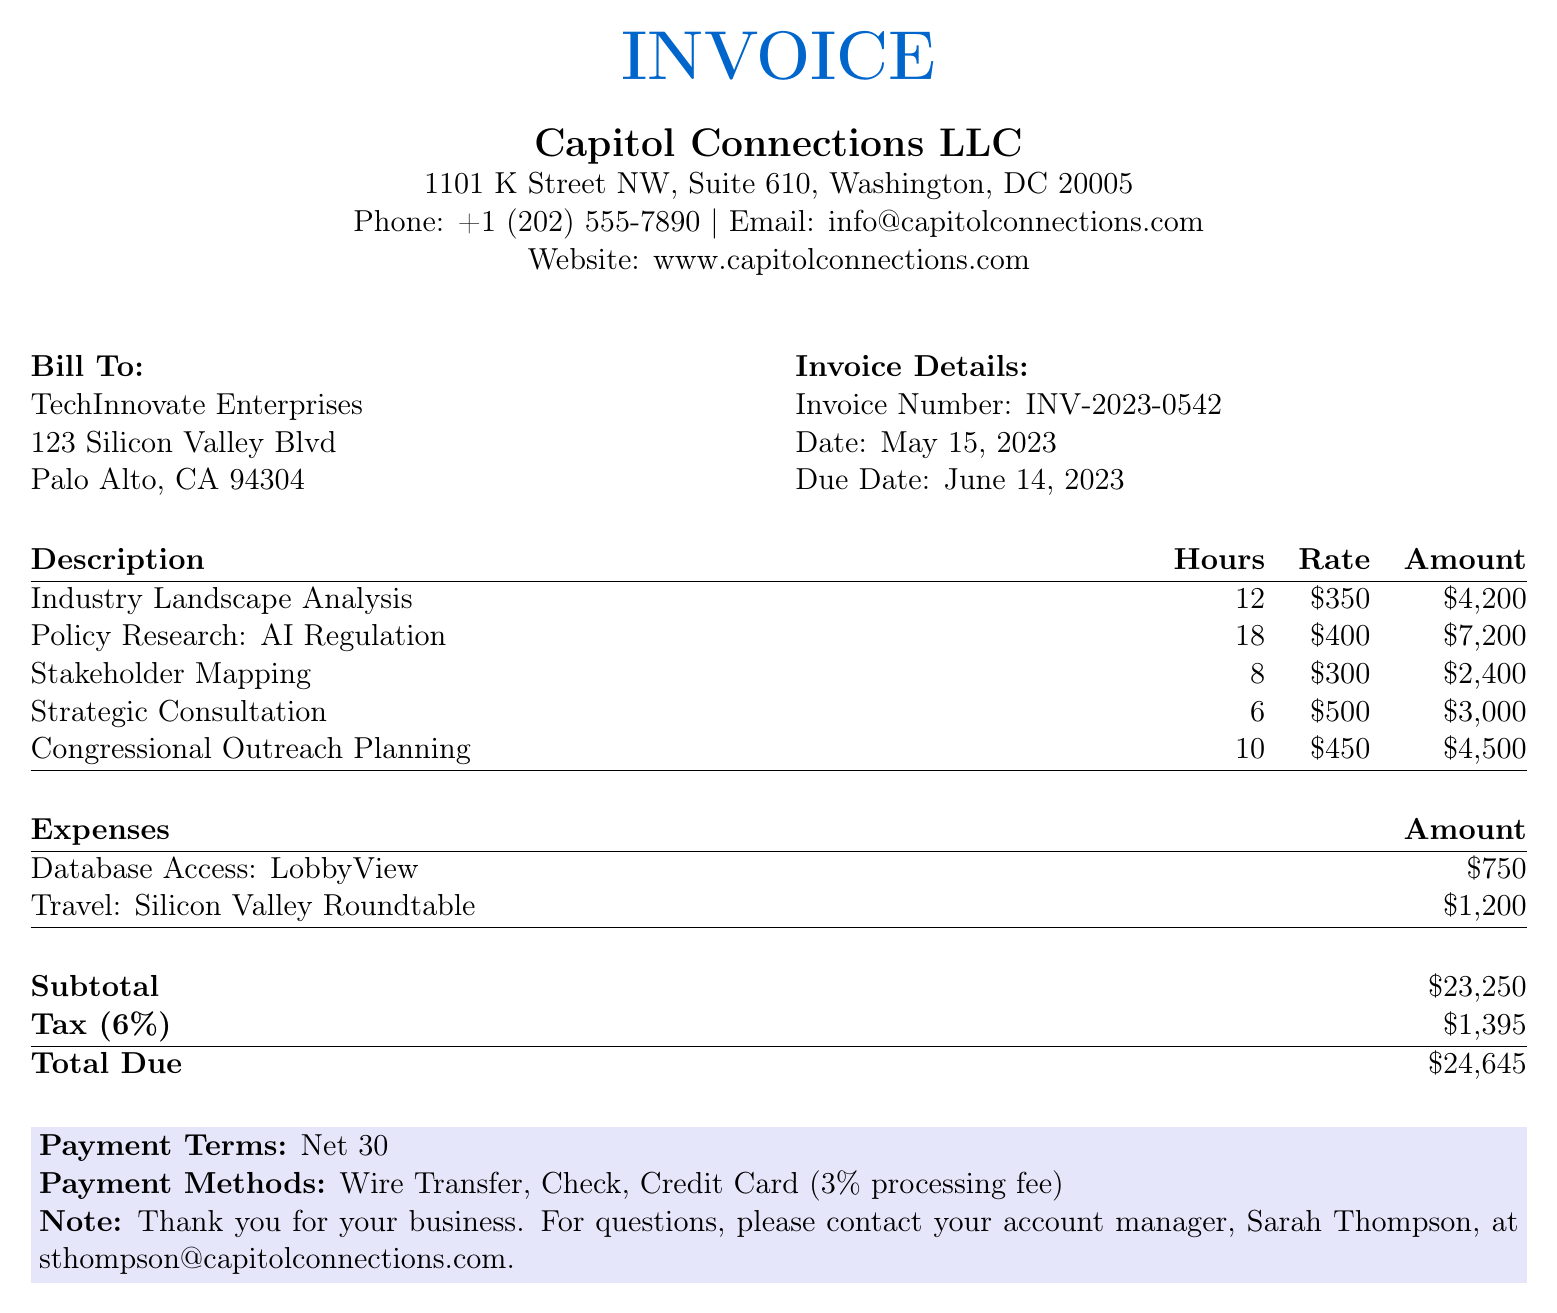what is the invoice number? The invoice number is listed under the invoice details section.
Answer: INV-2023-0542 what is the total due amount? The total due amount is calculated at the bottom of the invoice.
Answer: $24,645 who is the account manager to contact for questions? The name of the account manager is mentioned in the payment terms section.
Answer: Sarah Thompson how many hours were billed for policy research on AI regulation? The number of hours for this service is specified in the description table.
Answer: 18 what is the tax rate applied to the subtotal? The tax rate is indicated in the subtotal section.
Answer: 6% what is the amount billed for strategic consultation? The billed amount is found in the description table under the specific service.
Answer: $3,000 how many hours were dedicated to stakeholder mapping? The hours for stakeholder mapping are provided in the services table.
Answer: 8 what is the subtotal amount before tax? The subtotal is displayed in the invoice summary section.
Answer: $23,250 what payment methods are accepted? The accepted payment methods are listed in the payment terms section.
Answer: Wire Transfer, Check, Credit Card (3% processing fee) 